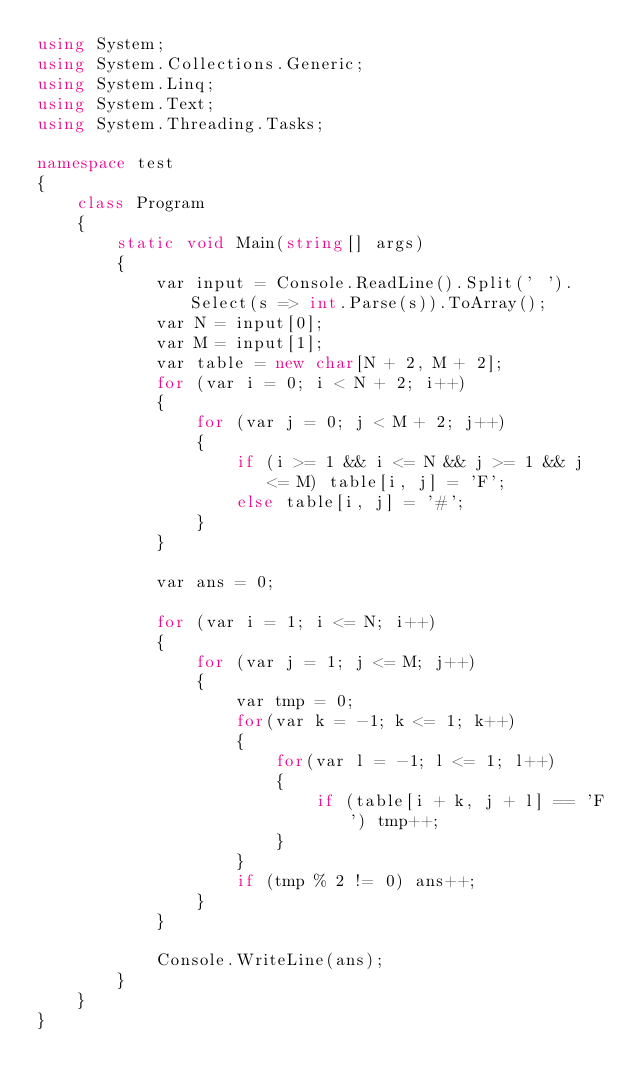<code> <loc_0><loc_0><loc_500><loc_500><_C#_>using System;
using System.Collections.Generic;
using System.Linq;
using System.Text;
using System.Threading.Tasks;

namespace test
{
    class Program
    {
        static void Main(string[] args)
        {
            var input = Console.ReadLine().Split(' ').Select(s => int.Parse(s)).ToArray();
            var N = input[0];
            var M = input[1];
            var table = new char[N + 2, M + 2];
            for (var i = 0; i < N + 2; i++)
            {
                for (var j = 0; j < M + 2; j++)
                {
                    if (i >= 1 && i <= N && j >= 1 && j <= M) table[i, j] = 'F';
                    else table[i, j] = '#';
                }
            }

            var ans = 0;

            for (var i = 1; i <= N; i++)
            {
                for (var j = 1; j <= M; j++)
                {
                    var tmp = 0;
                    for(var k = -1; k <= 1; k++)
                    {
                        for(var l = -1; l <= 1; l++)
                        {
                            if (table[i + k, j + l] == 'F') tmp++;
                        }
                    }
                    if (tmp % 2 != 0) ans++;
                }
            }
          
            Console.WriteLine(ans);
        }
    }
}</code> 